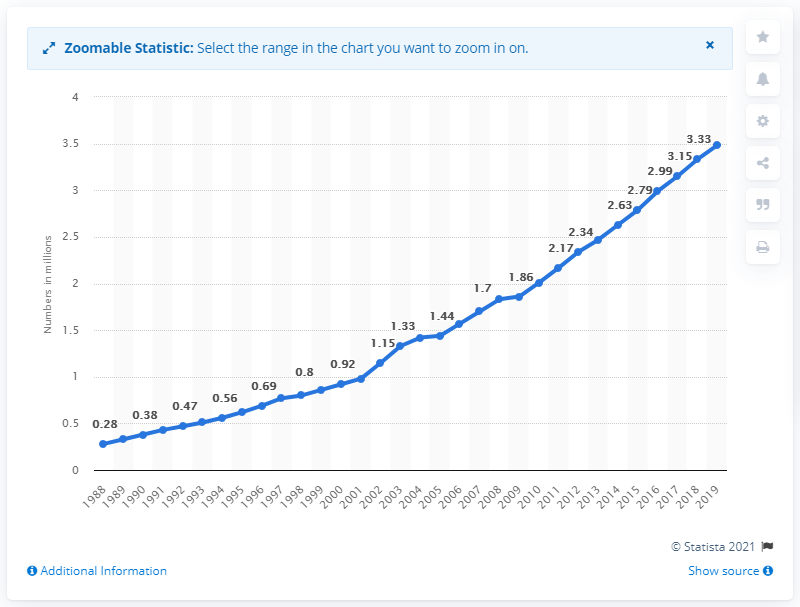Give some essential details in this illustration. In 2019, the number of registered private cars in Delhi was 3,480. 